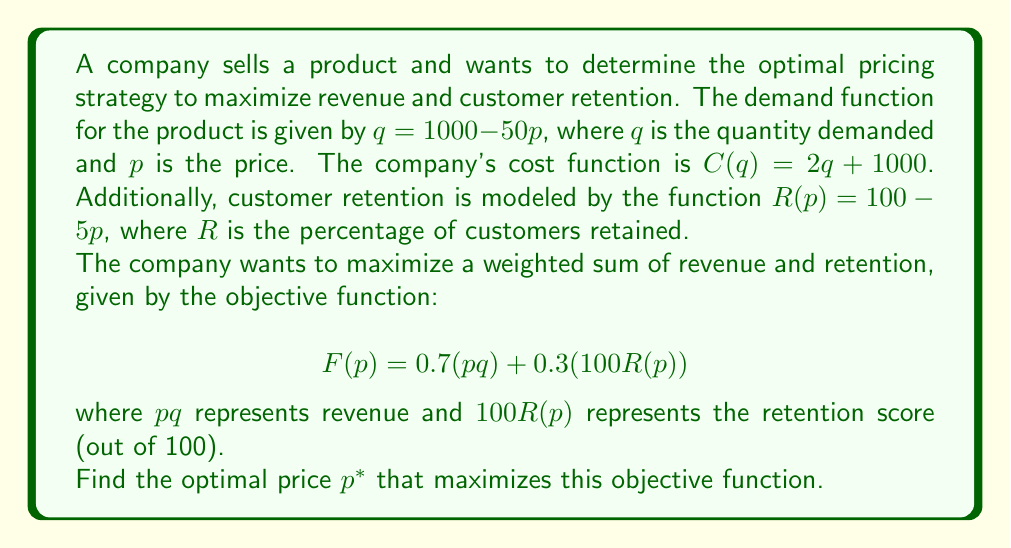Show me your answer to this math problem. To solve this optimization problem, we'll follow these steps:

1) Express $q$ in terms of $p$ using the demand function:
   $q = 1000 - 50p$

2) Substitute this into the objective function:
   $$F(p) = 0.7(p(1000 - 50p)) + 0.3(100(100 - 5p))$$

3) Expand the function:
   $$F(p) = 0.7(1000p - 50p^2) + 0.3(10000 - 500p)$$
   $$F(p) = 700p - 35p^2 + 3000 - 150p$$
   $$F(p) = -35p^2 + 550p + 3000$$

4) To find the maximum, we differentiate $F(p)$ with respect to $p$ and set it to zero:
   $$\frac{dF}{dp} = -70p + 550 = 0$$

5) Solve this equation:
   $$-70p + 550 = 0$$
   $$-70p = -550$$
   $$p = \frac{550}{70} = \frac{55}{7} \approx 7.86$$

6) To confirm this is a maximum, we can check the second derivative:
   $$\frac{d^2F}{dp^2} = -70$$
   Since this is negative, we confirm that $p = \frac{55}{7}$ gives a maximum.

7) Therefore, the optimal price $p^*$ is $\frac{55}{7}$.
Answer: The optimal price $p^*$ that maximizes the objective function is $\frac{55}{7}$ or approximately $7.86$. 